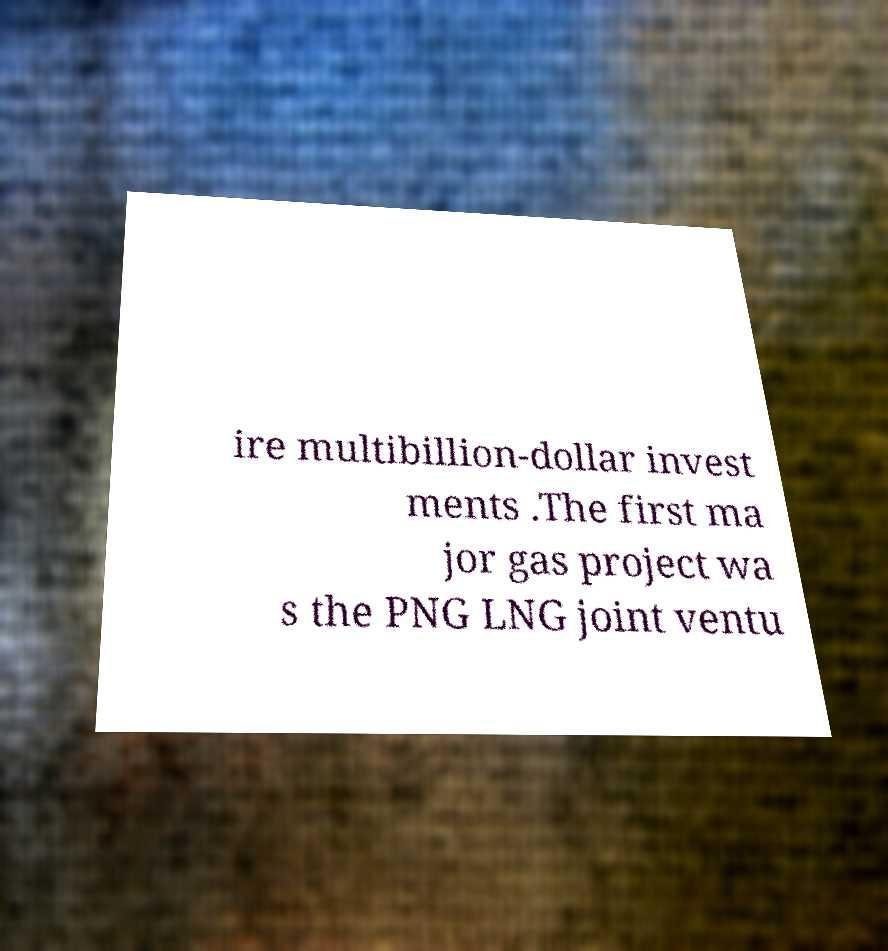Could you assist in decoding the text presented in this image and type it out clearly? ire multibillion-dollar invest ments .The first ma jor gas project wa s the PNG LNG joint ventu 